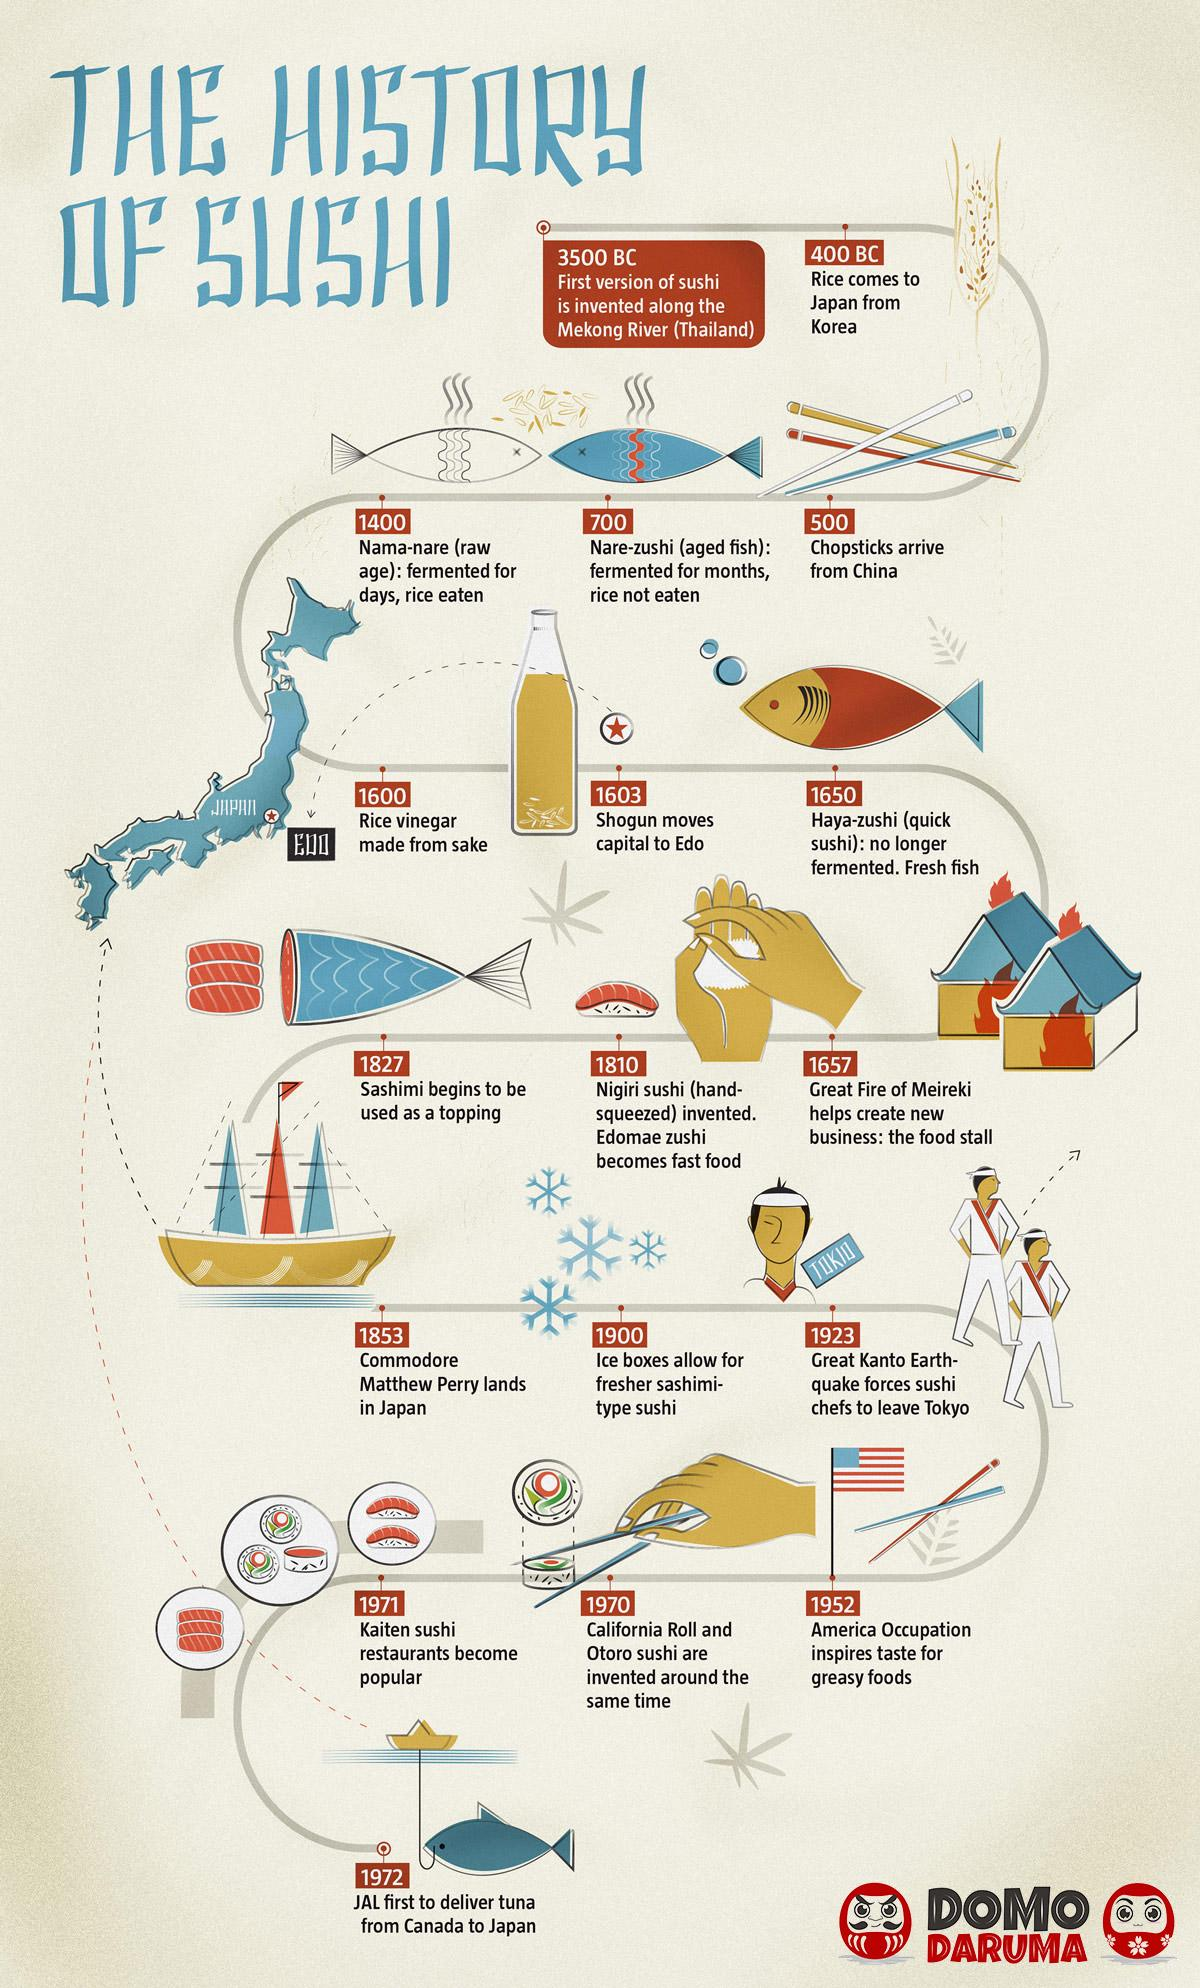Indicate a few pertinent items in this graphic. In 1923, sushi chefs left Tokyo. The food stall was created in 1657. Chopsticks were introduced in Japan approximately 500 years ago. The use of fresh fish in sushi dates back to the year 1650. Rice, having originated from Korea, arrived in its current location. 